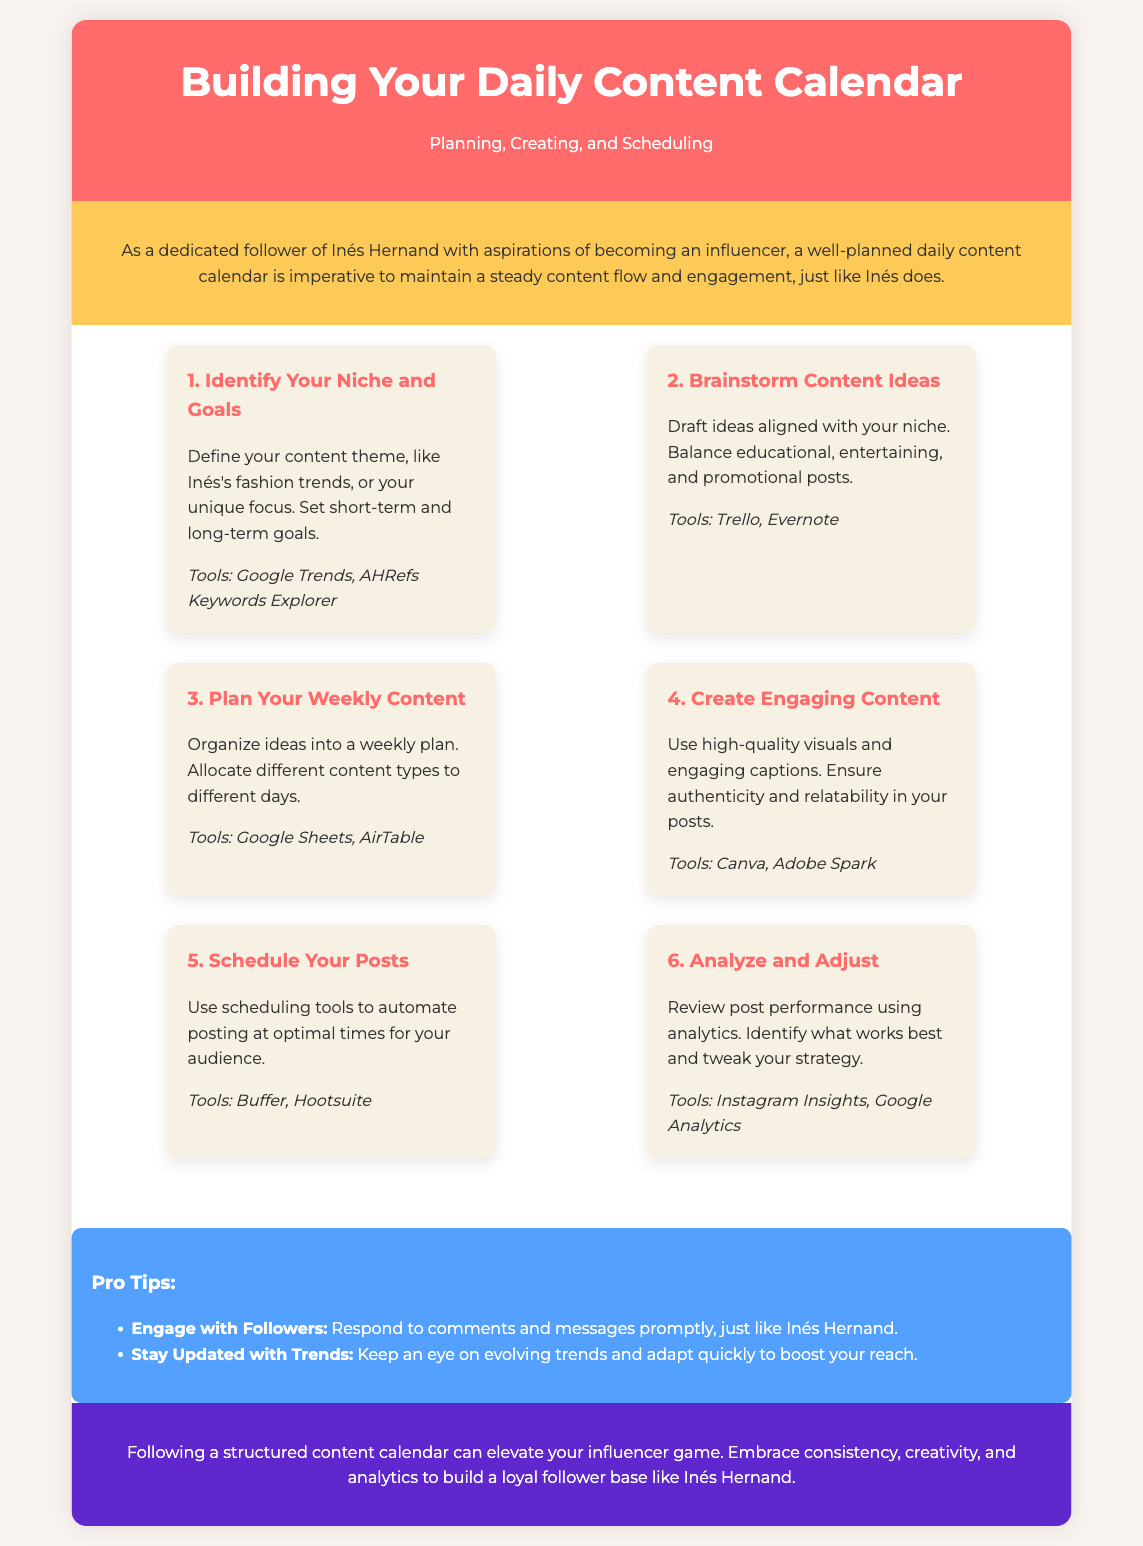what is the main theme of the content calendar? The main theme is about planning, creating, and scheduling content effectively for influencers.
Answer: planning, creating, and scheduling what is the first step in building a content calendar? The first step involves identifying your niche and goals for your content.
Answer: Identify Your Niche and Goals which tool is suggested for brainstorming content ideas? The infographic suggests using Trello for brainstorming content ideas.
Answer: Trello how many steps are there in the content building process? The infographic outlines a total of six steps in the content building process.
Answer: six what type of posts should be balanced in content ideas? The content ideas should balance educational, entertaining, and promotional posts.
Answer: educational, entertaining, and promotional which tool can be used to analyze post performance? Instagram Insights is recommended for analyzing post performance.
Answer: Instagram Insights what color is the conclusion section background? The conclusion section has a purple background color.
Answer: purple which step involves automating posting? The step that involves automating posting is scheduling your posts.
Answer: Schedule Your Posts who is a notable influencer mentioned in the document? Inés Hernand is the notable influencer referenced in the document.
Answer: Inés Hernand 